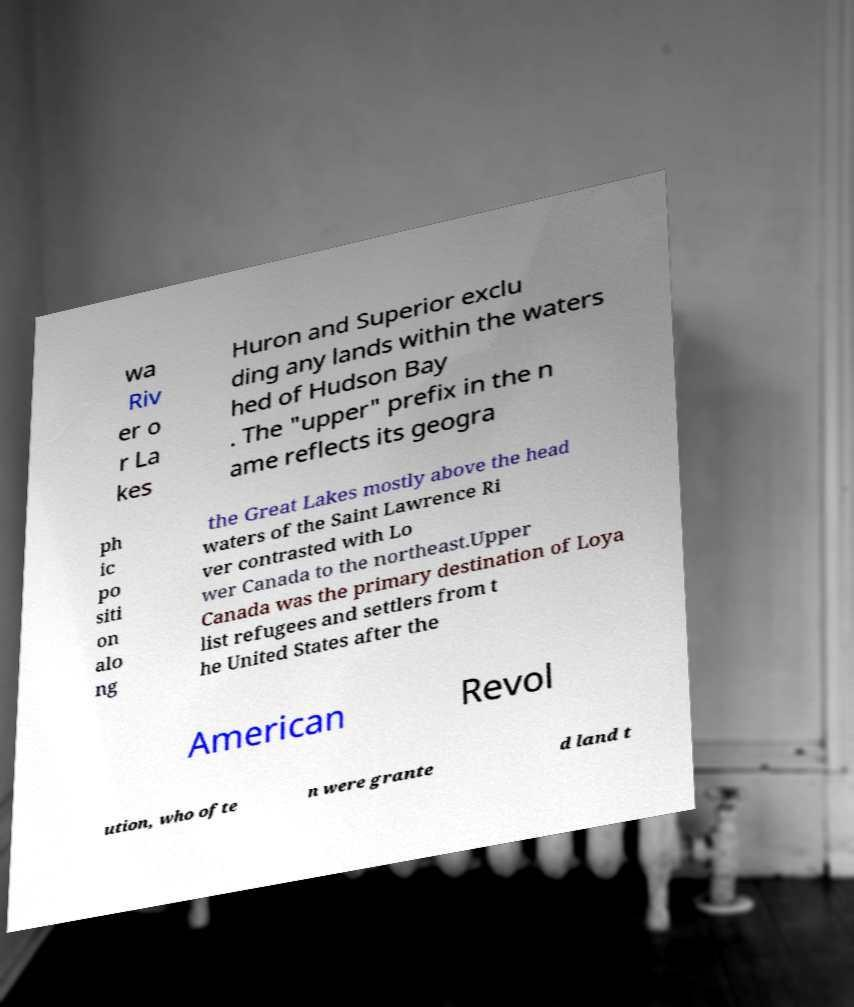Can you read and provide the text displayed in the image?This photo seems to have some interesting text. Can you extract and type it out for me? wa Riv er o r La kes Huron and Superior exclu ding any lands within the waters hed of Hudson Bay . The "upper" prefix in the n ame reflects its geogra ph ic po siti on alo ng the Great Lakes mostly above the head waters of the Saint Lawrence Ri ver contrasted with Lo wer Canada to the northeast.Upper Canada was the primary destination of Loya list refugees and settlers from t he United States after the American Revol ution, who ofte n were grante d land t 